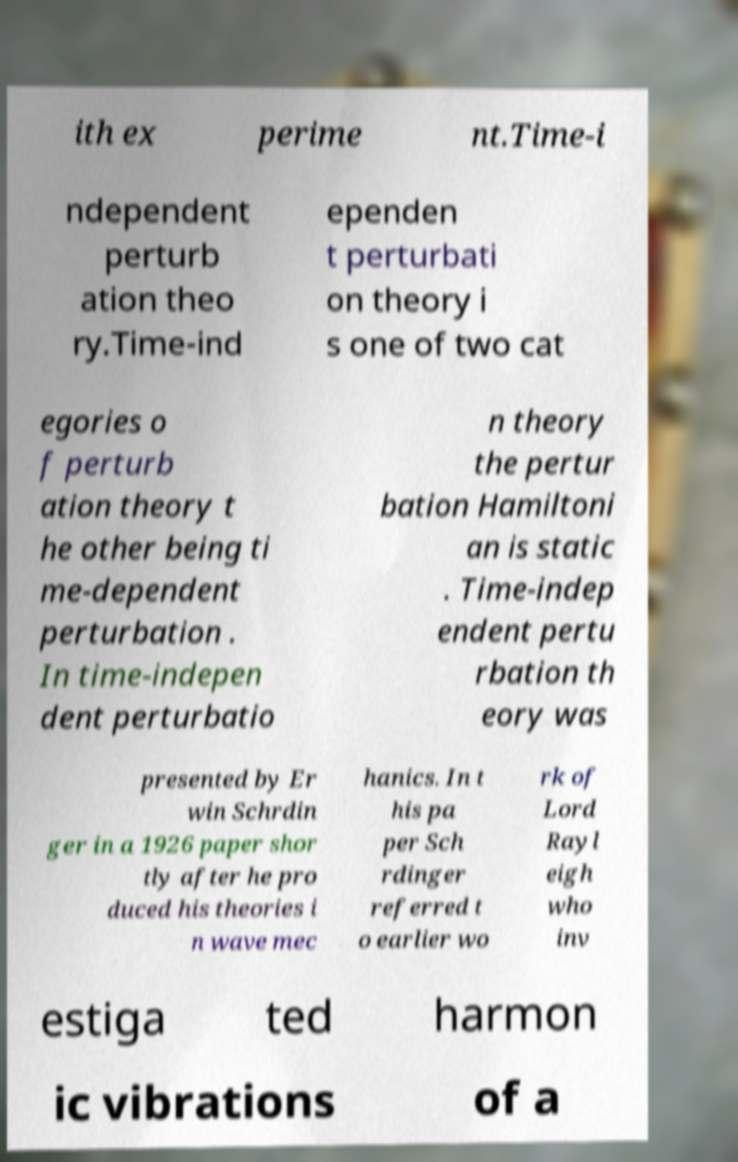For documentation purposes, I need the text within this image transcribed. Could you provide that? ith ex perime nt.Time-i ndependent perturb ation theo ry.Time-ind ependen t perturbati on theory i s one of two cat egories o f perturb ation theory t he other being ti me-dependent perturbation . In time-indepen dent perturbatio n theory the pertur bation Hamiltoni an is static . Time-indep endent pertu rbation th eory was presented by Er win Schrdin ger in a 1926 paper shor tly after he pro duced his theories i n wave mec hanics. In t his pa per Sch rdinger referred t o earlier wo rk of Lord Rayl eigh who inv estiga ted harmon ic vibrations of a 